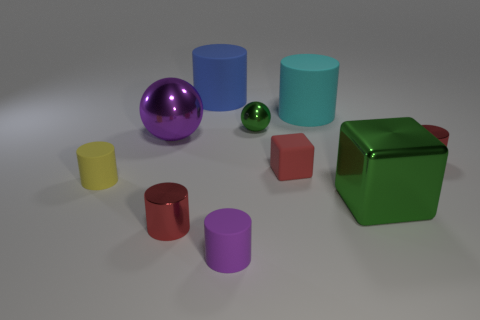Subtract all red cylinders. How many cylinders are left? 4 Subtract all large blue matte cylinders. How many cylinders are left? 5 Subtract 3 cylinders. How many cylinders are left? 3 Subtract all brown cylinders. Subtract all purple balls. How many cylinders are left? 6 Subtract all blocks. How many objects are left? 8 Add 5 red cylinders. How many red cylinders are left? 7 Add 6 tiny balls. How many tiny balls exist? 7 Subtract 1 green cubes. How many objects are left? 9 Subtract all red cubes. Subtract all purple objects. How many objects are left? 7 